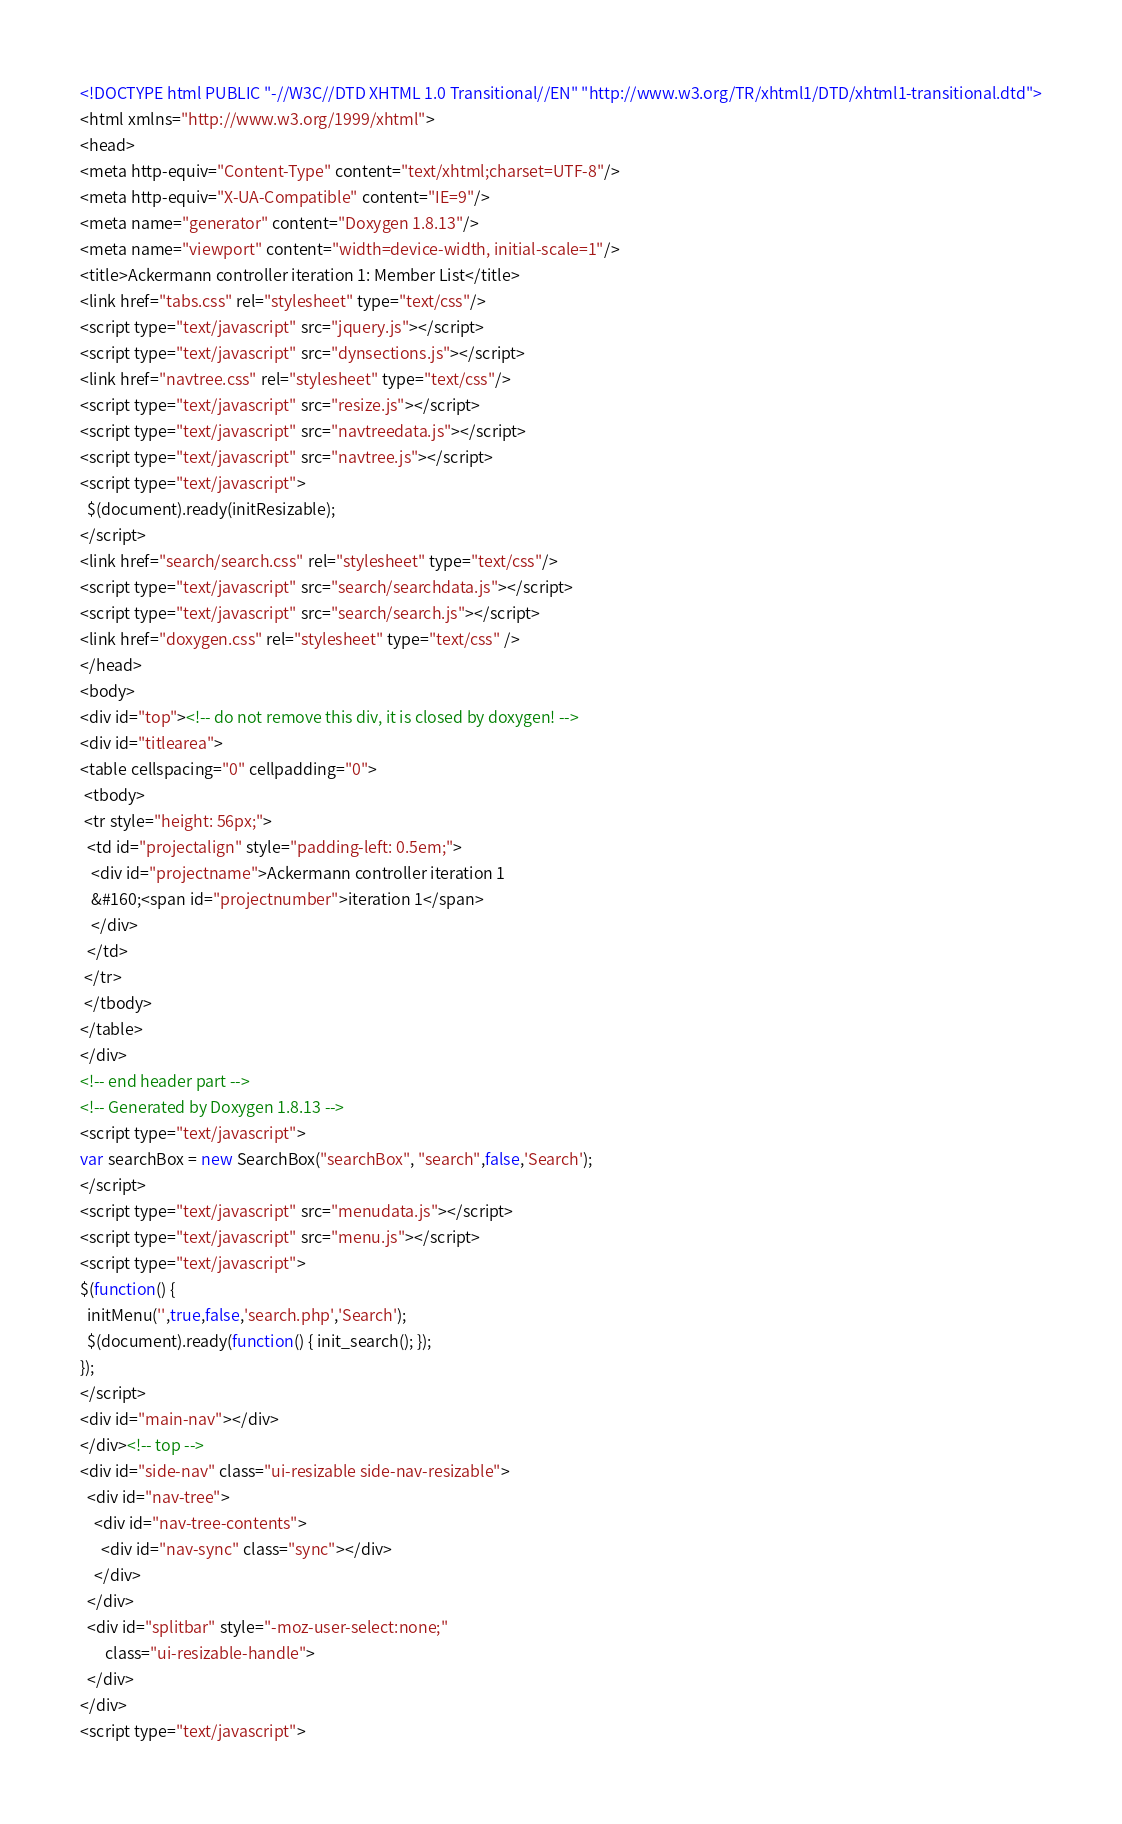Convert code to text. <code><loc_0><loc_0><loc_500><loc_500><_HTML_><!DOCTYPE html PUBLIC "-//W3C//DTD XHTML 1.0 Transitional//EN" "http://www.w3.org/TR/xhtml1/DTD/xhtml1-transitional.dtd">
<html xmlns="http://www.w3.org/1999/xhtml">
<head>
<meta http-equiv="Content-Type" content="text/xhtml;charset=UTF-8"/>
<meta http-equiv="X-UA-Compatible" content="IE=9"/>
<meta name="generator" content="Doxygen 1.8.13"/>
<meta name="viewport" content="width=device-width, initial-scale=1"/>
<title>Ackermann controller iteration 1: Member List</title>
<link href="tabs.css" rel="stylesheet" type="text/css"/>
<script type="text/javascript" src="jquery.js"></script>
<script type="text/javascript" src="dynsections.js"></script>
<link href="navtree.css" rel="stylesheet" type="text/css"/>
<script type="text/javascript" src="resize.js"></script>
<script type="text/javascript" src="navtreedata.js"></script>
<script type="text/javascript" src="navtree.js"></script>
<script type="text/javascript">
  $(document).ready(initResizable);
</script>
<link href="search/search.css" rel="stylesheet" type="text/css"/>
<script type="text/javascript" src="search/searchdata.js"></script>
<script type="text/javascript" src="search/search.js"></script>
<link href="doxygen.css" rel="stylesheet" type="text/css" />
</head>
<body>
<div id="top"><!-- do not remove this div, it is closed by doxygen! -->
<div id="titlearea">
<table cellspacing="0" cellpadding="0">
 <tbody>
 <tr style="height: 56px;">
  <td id="projectalign" style="padding-left: 0.5em;">
   <div id="projectname">Ackermann controller iteration 1
   &#160;<span id="projectnumber">iteration 1</span>
   </div>
  </td>
 </tr>
 </tbody>
</table>
</div>
<!-- end header part -->
<!-- Generated by Doxygen 1.8.13 -->
<script type="text/javascript">
var searchBox = new SearchBox("searchBox", "search",false,'Search');
</script>
<script type="text/javascript" src="menudata.js"></script>
<script type="text/javascript" src="menu.js"></script>
<script type="text/javascript">
$(function() {
  initMenu('',true,false,'search.php','Search');
  $(document).ready(function() { init_search(); });
});
</script>
<div id="main-nav"></div>
</div><!-- top -->
<div id="side-nav" class="ui-resizable side-nav-resizable">
  <div id="nav-tree">
    <div id="nav-tree-contents">
      <div id="nav-sync" class="sync"></div>
    </div>
  </div>
  <div id="splitbar" style="-moz-user-select:none;" 
       class="ui-resizable-handle">
  </div>
</div>
<script type="text/javascript"></code> 